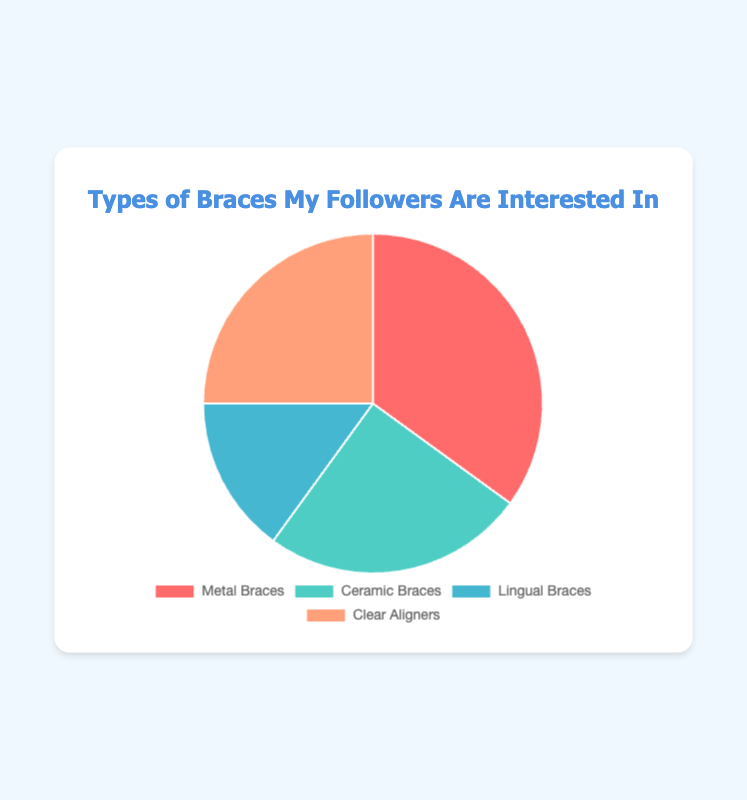What percentage of followers are interested in Clear Aligners? The figure shows that the percentage of followers interested in Clear Aligners is displayed in one of the segments of the pie chart. Clear Aligners' segment is labeled with its percentage.
Answer: 25% Which type of braces has the highest interest among my followers? By examining the pie chart, we can see that the largest segment represents Metal Braces. The percentage for Metal Braces is the highest compared to other types.
Answer: Metal Braces How does the interest in Ceramic Braces compare to Lingual Braces? The pie chart shows both percentages: Ceramic Braces at 25% and Lingual Braces at 15%. By comparing these values, we can see that Ceramic Braces have a higher percentage of interest.
Answer: Ceramic Braces have a higher interest If you combine the interest in Ceramic Braces and Clear Aligners, what percentage of followers does that represent? Adding the percentages for Ceramic Braces (25%) and Clear Aligners (25%), you get the combined percentage.
Answer: 50% What is the difference in interest between the most popular and least popular types of braces? The most popular type is Metal Braces at 35%, and the least popular is Lingual Braces at 15%. The difference is calculated by subtracting the percentage of Lingual Braces from Metal Braces.
Answer: 20% Which two types of braces have equal interest among my followers? By looking at the pie chart, we identify two segments with matching percentages. Ceramic Braces and Clear Aligners both have 25%.
Answer: Ceramic Braces and Clear Aligners What is the total percentage of followers interested in Metal and Lingual Braces combined? Sum the percentages for Metal Braces (35%) and Lingual Braces (15%), resulting in the total.
Answer: 50% How many different colors are used in the pie chart to represent the types of braces? There is a visual inspection of the pie chart segments and counting the distinct colors represented.
Answer: 4 How much greater is the interest in Metal Braces compared to Clear Aligners? The interest in Metal Braces (35%) is compared to Clear Aligners (25%). The difference is calculated by subtracting the percentage of Clear Aligners from Metal Braces.
Answer: 10% 